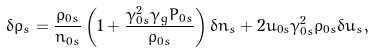<formula> <loc_0><loc_0><loc_500><loc_500>\delta \rho _ { s } = \frac { \rho _ { 0 s } } { n _ { 0 s } } \left ( 1 + \frac { \gamma _ { 0 s } ^ { 2 } \gamma _ { g } P _ { 0 s } } { \rho _ { 0 s } } \right ) \delta n _ { s } + 2 u _ { 0 s } \gamma _ { 0 s } ^ { 2 } \rho _ { 0 s } \delta u _ { s } ,</formula> 